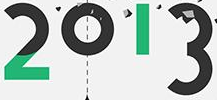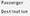What words are shown in these images in order, separated by a semicolon? 2013; # 